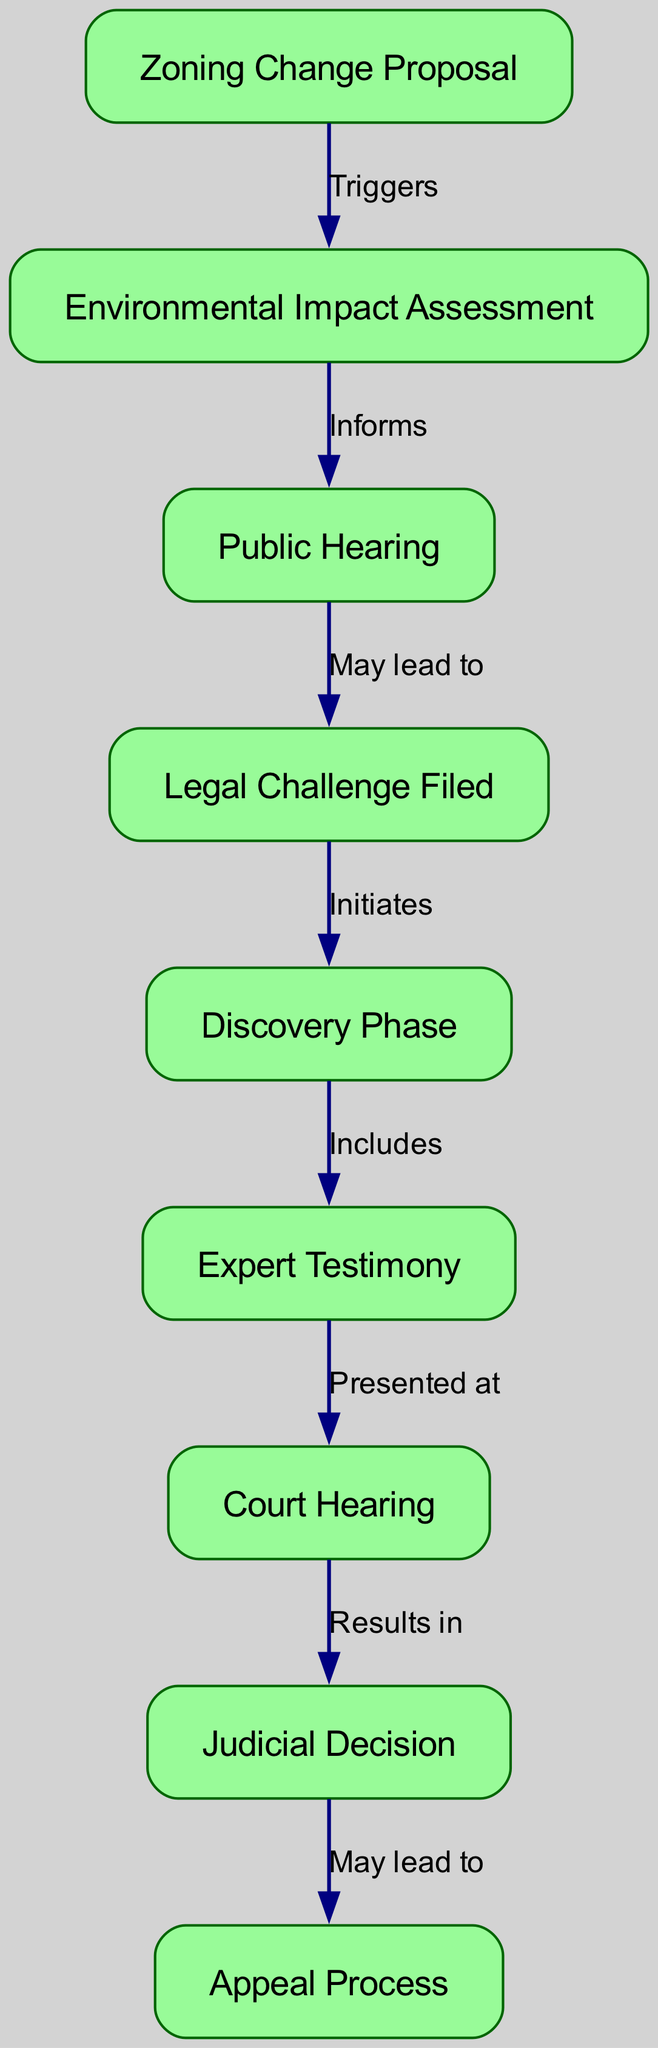What is the first step in the lifecycle? The first step according to the diagram is the "Zoning Change Proposal," which triggers the subsequent actions in the legal case lifecycle.
Answer: Zoning Change Proposal How many nodes are there in total? By counting all unique entities listed in the diagram, there are 9 nodes representing distinct steps or components in the legal case lifecycle.
Answer: 9 What label describes the relationship between "Environmental Impact Assessment" and "Public Hearing"? The diagram indicates that the "Environmental Impact Assessment" informs the "Public Hearing," highlighting its role in providing necessary information for the proceedings.
Answer: Informs What comes after the "Legal Challenge Filed"? The step that follows the "Legal Challenge Filed" in the diagram is the "Discovery Phase," showing the next procedural phase after a legal challenge is initiated.
Answer: Discovery Phase What is the last step before potentially entering the appeal? The last step indicated before the "Appeal Process" is the "Judicial Decision," which concludes the court proceedings and can lead to an appeal if necessary.
Answer: Judicial Decision Which step may lead to a public hearing? The diagram depicts that the "Public Hearing" may result directly from previous steps, specifically from the "Environmental Impact Assessment," signifying a need for public input based on the assessment.
Answer: May lead to How many edges connect the nodes? The number of edges is determined by counting all the directed relationships present in the diagram, which totals 8 connections between different steps of the lifecycle.
Answer: 8 What is the role of expert testimony in the lifecycle? The "Expert Testimony" phase is presented at the "Court Hearing," indicating that it serves as critical evidence in the judicial process.
Answer: Presented at What is the relationship between "Court Hearing" and "Judicial Decision"? The relationship outlined in the diagram is that the "Court Hearing" results in a "Judicial Decision," reflecting the outcome of court proceedings based on presented cases.
Answer: Results in 